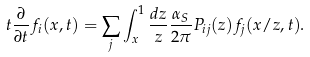<formula> <loc_0><loc_0><loc_500><loc_500>t \frac { \partial } { \partial t } f _ { i } ( x , t ) = \sum _ { j } \int _ { x } ^ { 1 } \frac { d z } { z } \frac { \alpha _ { S } } { 2 \pi } P _ { i j } ( z ) f _ { j } ( x / z , t ) .</formula> 